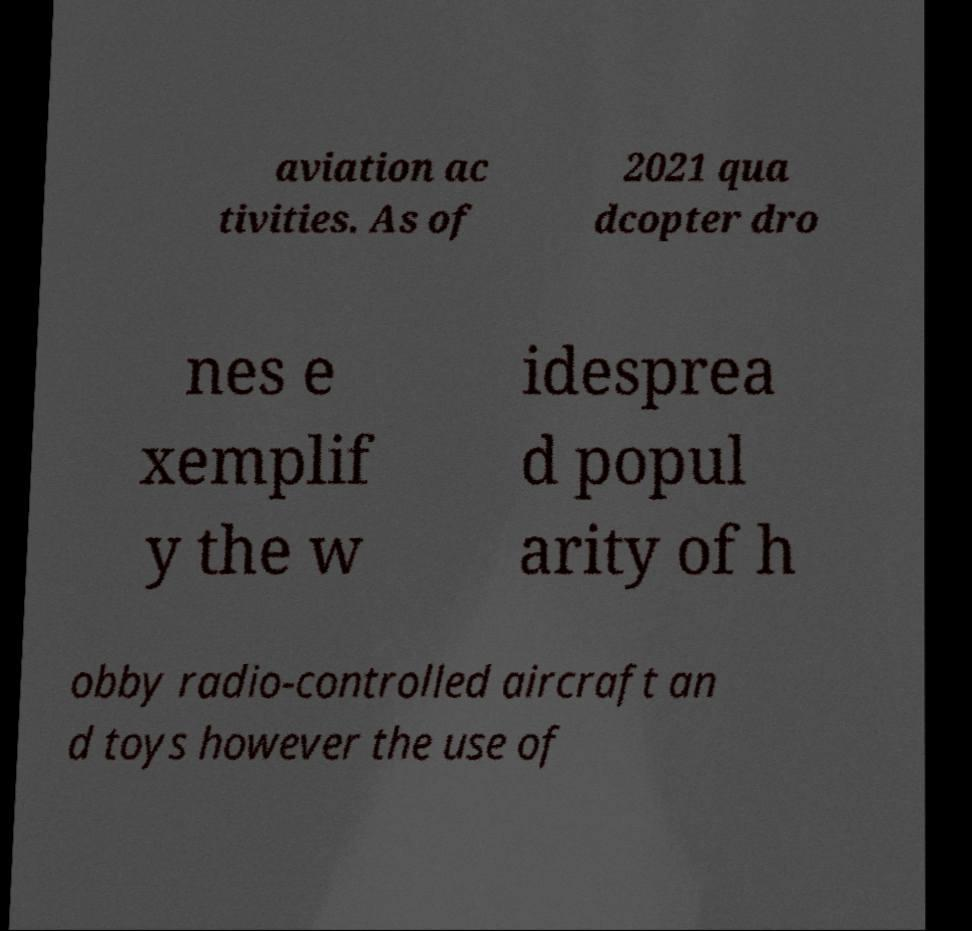Please read and relay the text visible in this image. What does it say? aviation ac tivities. As of 2021 qua dcopter dro nes e xemplif y the w idesprea d popul arity of h obby radio-controlled aircraft an d toys however the use of 